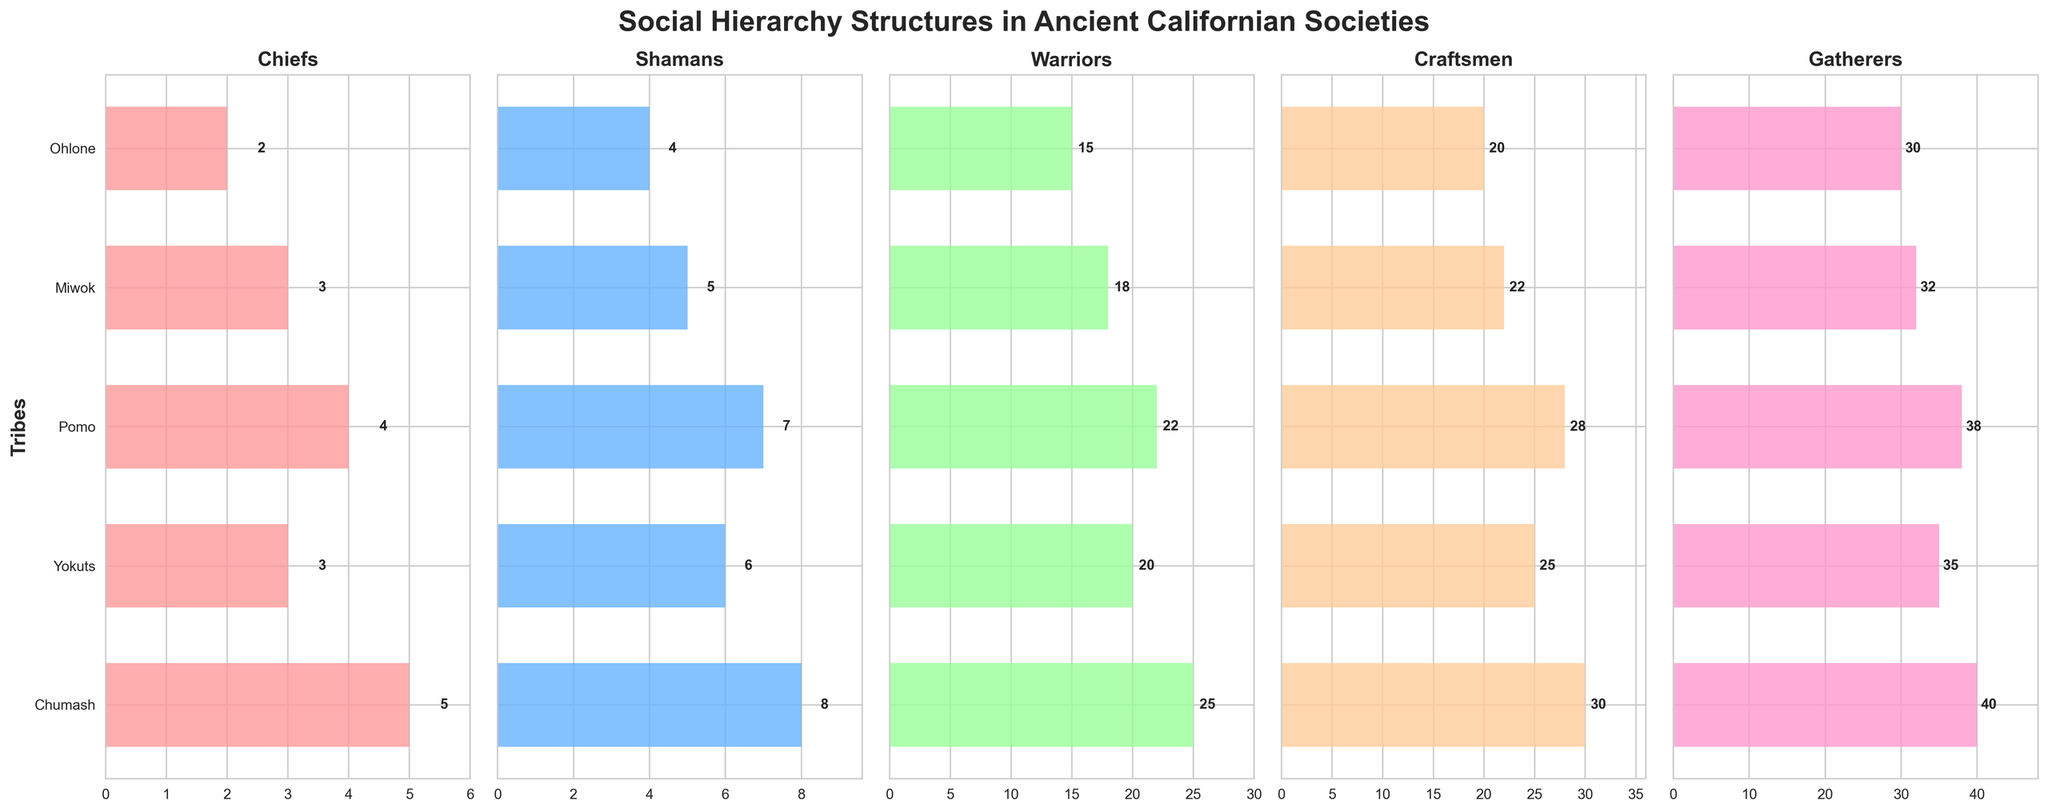What is the title of the figure? The title is usually located at the top of the figure and describes what the figure is about. For this figure, the title is "Social Hierarchy Structures in Ancient Californian Societies".
Answer: Social Hierarchy Structures in Ancient Californian Societies Which tribe has the highest number of Chiefs? To find the tribe with the highest number of Chiefs, look at the "Chiefs" column subplot and identify the highest bar. The tallest bar in this subplot belongs to the Chumash tribe.
Answer: Chumash How many Shamans does the Miwok tribe have? Locate the Shamans subplot and find the bar corresponding to the Miwok tribe, then read the value at the end of it. The Miwok tribe has 5 Shamans.
Answer: 5 Which role does the Ohlone tribe have the least of? For Ohlone, check all bars in each subplot and identify which is the shortest. The shortest bar corresponds to the number of Chiefs.
Answer: Chiefs What is the total number of social roles counted for the Chumash tribe? Add the values for all five roles in the Chumash row: 5 (Chiefs) + 8 (Shamans) + 25 (Warriors) + 30 (Craftsmen) + 40 (Gatherers). The total is 108.
Answer: 108 Which tribe has more Warriors, Yokuts or Pomo? Compare the values for Warriors in the Yokuts and Pomo rows. Yokuts have 20 Warriors, and Pomo have 22 Warriors. Pomo have more Warriors.
Answer: Pomo What is the average number of Gatherers across all tribes? Add the values for Gatherers from all tribes and divide by the number of tribes: (40 + 35 + 38 + 32 + 30) / 5 = 35.
Answer: 35 Are there more Craftsmen or Shamans in the Yokuts tribe? Compare the numbers of Craftsmen and Shamans in the Yokuts row. Yokuts have 25 Craftsmen and 6 Shamans, so there are more Craftsmen.
Answer: Craftsmen What role is most populous in the Pomo tribe? Identify the role with the highest number in the Pomo row. The role "Gatherers" has the highest number with 38 individuals.
Answer: Gatherers 